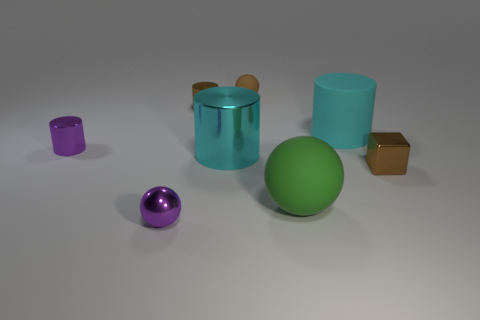Do the tiny matte ball and the tiny metallic cube have the same color?
Your response must be concise. Yes. How many cylinders are in front of the big cyan rubber thing and to the right of the tiny brown ball?
Provide a succinct answer. 0. Do the brown object behind the brown metallic cylinder and the large cyan metallic cylinder have the same size?
Make the answer very short. No. Is there a small cylinder of the same color as the small metallic ball?
Keep it short and to the point. Yes. There is a cyan object that is made of the same material as the small brown ball; what is its size?
Provide a succinct answer. Large. Are there more shiny cylinders that are in front of the brown cylinder than large rubber spheres that are behind the large green matte ball?
Provide a short and direct response. Yes. How many other objects are the same material as the block?
Your answer should be very brief. 4. Are the tiny sphere that is in front of the brown cube and the tiny brown sphere made of the same material?
Keep it short and to the point. No. The large cyan metal thing has what shape?
Keep it short and to the point. Cylinder. Is the number of small metallic cylinders that are behind the large matte sphere greater than the number of tiny gray blocks?
Provide a short and direct response. Yes. 